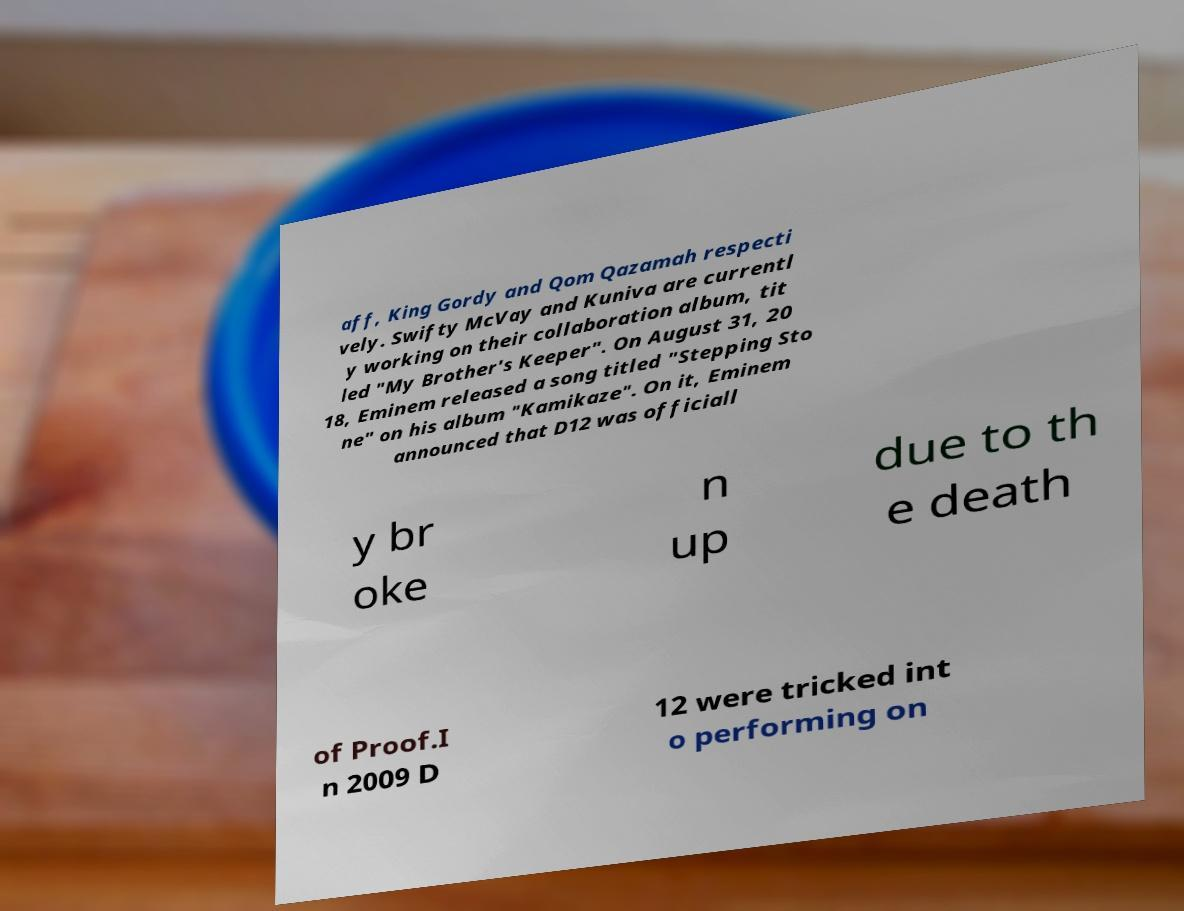Could you extract and type out the text from this image? aff, King Gordy and Qom Qazamah respecti vely. Swifty McVay and Kuniva are currentl y working on their collaboration album, tit led "My Brother's Keeper". On August 31, 20 18, Eminem released a song titled "Stepping Sto ne" on his album "Kamikaze". On it, Eminem announced that D12 was officiall y br oke n up due to th e death of Proof.I n 2009 D 12 were tricked int o performing on 